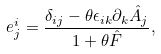Convert formula to latex. <formula><loc_0><loc_0><loc_500><loc_500>e ^ { i } _ { j } = \frac { \delta _ { i j } - \theta \epsilon _ { i k } \partial _ { k } \hat { A } _ { j } } { 1 + \theta \hat { F } } ,</formula> 